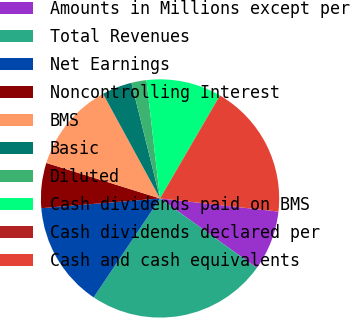Convert chart. <chart><loc_0><loc_0><loc_500><loc_500><pie_chart><fcel>Amounts in Millions except per<fcel>Total Revenues<fcel>Net Earnings<fcel>Noncontrolling Interest<fcel>BMS<fcel>Basic<fcel>Diluted<fcel>Cash dividends paid on BMS<fcel>Cash dividends declared per<fcel>Cash and cash equivalents<nl><fcel>8.16%<fcel>24.49%<fcel>14.29%<fcel>6.12%<fcel>12.24%<fcel>4.08%<fcel>2.04%<fcel>10.2%<fcel>0.0%<fcel>18.37%<nl></chart> 